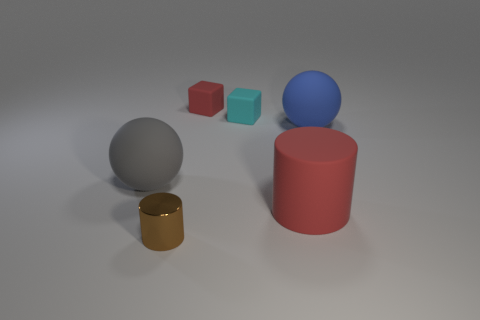What number of brown cylinders are the same size as the cyan object?
Keep it short and to the point. 1. Is the number of matte things that are to the left of the small brown metal cylinder less than the number of tiny cubes?
Your answer should be very brief. Yes. There is a tiny brown thing; what number of rubber blocks are on the right side of it?
Your answer should be very brief. 2. There is a red thing that is behind the large rubber thing in front of the large rubber thing to the left of the brown cylinder; how big is it?
Make the answer very short. Small. There is a brown object; is it the same shape as the rubber object left of the small metal thing?
Your answer should be compact. No. There is a gray thing that is the same material as the blue thing; what size is it?
Keep it short and to the point. Large. Is there any other thing of the same color as the small cylinder?
Ensure brevity in your answer.  No. What material is the large object that is on the left side of the big thing that is in front of the big thing to the left of the brown object?
Offer a very short reply. Rubber. How many rubber objects are either big red objects or small blocks?
Your response must be concise. 3. Are there any other things that are made of the same material as the tiny brown cylinder?
Provide a short and direct response. No. 